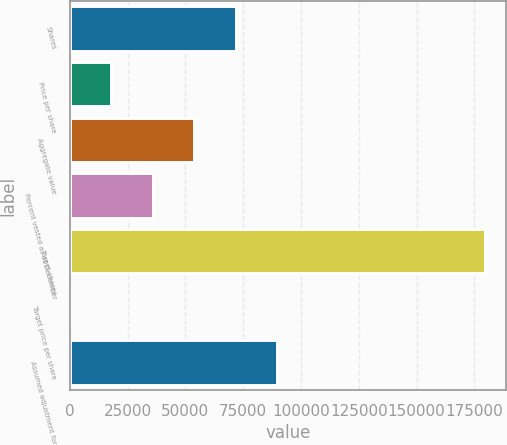<chart> <loc_0><loc_0><loc_500><loc_500><bar_chart><fcel>Shares<fcel>Price per share<fcel>Aggregate value<fcel>Percent vested as of December<fcel>Target shares<fcel>Target price per share<fcel>Assumed adjustment for<nl><fcel>71832.2<fcel>17998.2<fcel>53887.5<fcel>35942.9<fcel>179500<fcel>53.61<fcel>89776.8<nl></chart> 